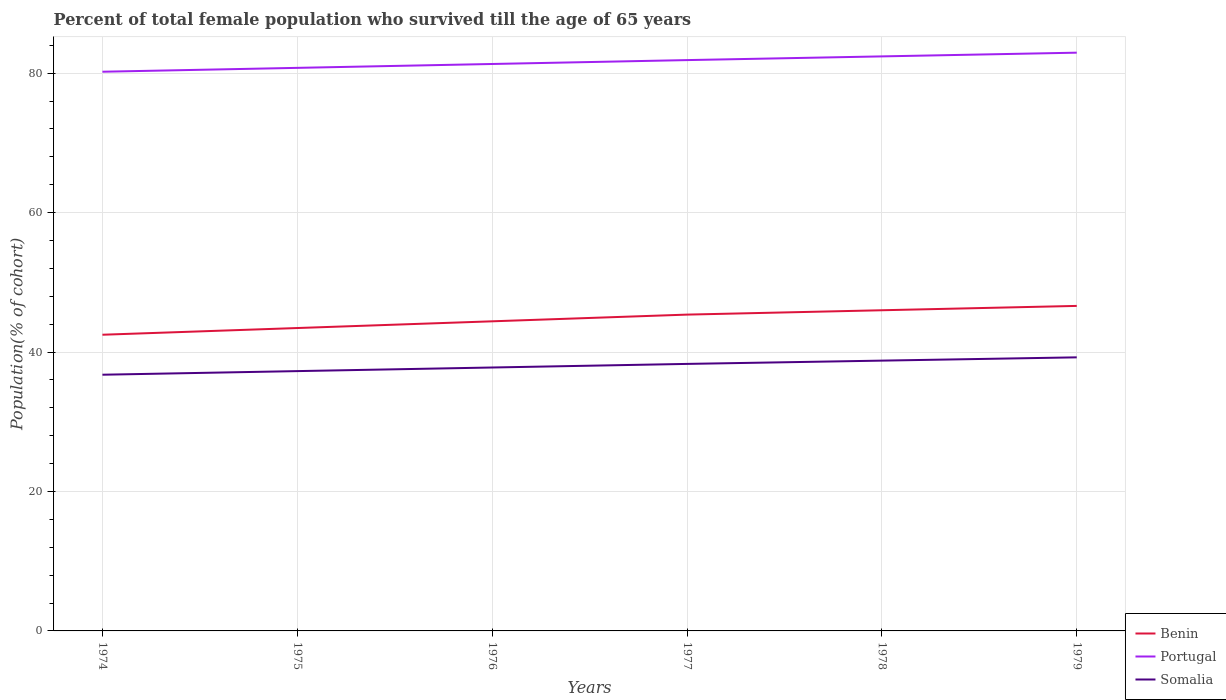Is the number of lines equal to the number of legend labels?
Your answer should be very brief. Yes. Across all years, what is the maximum percentage of total female population who survived till the age of 65 years in Benin?
Your answer should be compact. 42.48. In which year was the percentage of total female population who survived till the age of 65 years in Somalia maximum?
Offer a very short reply. 1974. What is the total percentage of total female population who survived till the age of 65 years in Portugal in the graph?
Keep it short and to the point. -0.53. What is the difference between the highest and the second highest percentage of total female population who survived till the age of 65 years in Portugal?
Make the answer very short. 2.73. What is the difference between the highest and the lowest percentage of total female population who survived till the age of 65 years in Portugal?
Offer a terse response. 3. Is the percentage of total female population who survived till the age of 65 years in Benin strictly greater than the percentage of total female population who survived till the age of 65 years in Somalia over the years?
Give a very brief answer. No. How many years are there in the graph?
Ensure brevity in your answer.  6. Are the values on the major ticks of Y-axis written in scientific E-notation?
Provide a short and direct response. No. Does the graph contain any zero values?
Your answer should be compact. No. How many legend labels are there?
Offer a terse response. 3. How are the legend labels stacked?
Offer a very short reply. Vertical. What is the title of the graph?
Your answer should be very brief. Percent of total female population who survived till the age of 65 years. What is the label or title of the X-axis?
Provide a succinct answer. Years. What is the label or title of the Y-axis?
Provide a short and direct response. Population(% of cohort). What is the Population(% of cohort) in Benin in 1974?
Provide a short and direct response. 42.48. What is the Population(% of cohort) in Portugal in 1974?
Your response must be concise. 80.2. What is the Population(% of cohort) of Somalia in 1974?
Your response must be concise. 36.75. What is the Population(% of cohort) in Benin in 1975?
Offer a terse response. 43.44. What is the Population(% of cohort) of Portugal in 1975?
Your response must be concise. 80.76. What is the Population(% of cohort) in Somalia in 1975?
Offer a very short reply. 37.26. What is the Population(% of cohort) in Benin in 1976?
Ensure brevity in your answer.  44.4. What is the Population(% of cohort) in Portugal in 1976?
Provide a succinct answer. 81.31. What is the Population(% of cohort) in Somalia in 1976?
Provide a succinct answer. 37.78. What is the Population(% of cohort) of Benin in 1977?
Make the answer very short. 45.37. What is the Population(% of cohort) in Portugal in 1977?
Make the answer very short. 81.87. What is the Population(% of cohort) in Somalia in 1977?
Your answer should be very brief. 38.3. What is the Population(% of cohort) of Benin in 1978?
Your answer should be very brief. 45.99. What is the Population(% of cohort) in Portugal in 1978?
Your answer should be very brief. 82.4. What is the Population(% of cohort) in Somalia in 1978?
Your response must be concise. 38.77. What is the Population(% of cohort) in Benin in 1979?
Provide a succinct answer. 46.61. What is the Population(% of cohort) in Portugal in 1979?
Ensure brevity in your answer.  82.93. What is the Population(% of cohort) in Somalia in 1979?
Ensure brevity in your answer.  39.24. Across all years, what is the maximum Population(% of cohort) of Benin?
Ensure brevity in your answer.  46.61. Across all years, what is the maximum Population(% of cohort) of Portugal?
Offer a very short reply. 82.93. Across all years, what is the maximum Population(% of cohort) of Somalia?
Offer a very short reply. 39.24. Across all years, what is the minimum Population(% of cohort) of Benin?
Provide a succinct answer. 42.48. Across all years, what is the minimum Population(% of cohort) of Portugal?
Your answer should be very brief. 80.2. Across all years, what is the minimum Population(% of cohort) in Somalia?
Your response must be concise. 36.75. What is the total Population(% of cohort) in Benin in the graph?
Your answer should be very brief. 268.3. What is the total Population(% of cohort) of Portugal in the graph?
Ensure brevity in your answer.  489.47. What is the total Population(% of cohort) of Somalia in the graph?
Provide a succinct answer. 228.09. What is the difference between the Population(% of cohort) in Benin in 1974 and that in 1975?
Your answer should be compact. -0.96. What is the difference between the Population(% of cohort) in Portugal in 1974 and that in 1975?
Offer a very short reply. -0.56. What is the difference between the Population(% of cohort) in Somalia in 1974 and that in 1975?
Your answer should be compact. -0.52. What is the difference between the Population(% of cohort) of Benin in 1974 and that in 1976?
Offer a very short reply. -1.92. What is the difference between the Population(% of cohort) of Portugal in 1974 and that in 1976?
Your response must be concise. -1.11. What is the difference between the Population(% of cohort) in Somalia in 1974 and that in 1976?
Your answer should be compact. -1.03. What is the difference between the Population(% of cohort) of Benin in 1974 and that in 1977?
Make the answer very short. -2.89. What is the difference between the Population(% of cohort) in Portugal in 1974 and that in 1977?
Provide a short and direct response. -1.67. What is the difference between the Population(% of cohort) of Somalia in 1974 and that in 1977?
Your response must be concise. -1.55. What is the difference between the Population(% of cohort) of Benin in 1974 and that in 1978?
Provide a short and direct response. -3.51. What is the difference between the Population(% of cohort) of Portugal in 1974 and that in 1978?
Offer a terse response. -2.2. What is the difference between the Population(% of cohort) in Somalia in 1974 and that in 1978?
Offer a very short reply. -2.02. What is the difference between the Population(% of cohort) of Benin in 1974 and that in 1979?
Provide a succinct answer. -4.13. What is the difference between the Population(% of cohort) of Portugal in 1974 and that in 1979?
Make the answer very short. -2.73. What is the difference between the Population(% of cohort) in Somalia in 1974 and that in 1979?
Make the answer very short. -2.49. What is the difference between the Population(% of cohort) in Benin in 1975 and that in 1976?
Your answer should be compact. -0.96. What is the difference between the Population(% of cohort) of Portugal in 1975 and that in 1976?
Provide a short and direct response. -0.56. What is the difference between the Population(% of cohort) of Somalia in 1975 and that in 1976?
Provide a succinct answer. -0.52. What is the difference between the Population(% of cohort) of Benin in 1975 and that in 1977?
Ensure brevity in your answer.  -1.92. What is the difference between the Population(% of cohort) of Portugal in 1975 and that in 1977?
Provide a short and direct response. -1.11. What is the difference between the Population(% of cohort) of Somalia in 1975 and that in 1977?
Give a very brief answer. -1.03. What is the difference between the Population(% of cohort) of Benin in 1975 and that in 1978?
Provide a short and direct response. -2.55. What is the difference between the Population(% of cohort) in Portugal in 1975 and that in 1978?
Your answer should be very brief. -1.65. What is the difference between the Population(% of cohort) in Somalia in 1975 and that in 1978?
Keep it short and to the point. -1.5. What is the difference between the Population(% of cohort) in Benin in 1975 and that in 1979?
Keep it short and to the point. -3.17. What is the difference between the Population(% of cohort) in Portugal in 1975 and that in 1979?
Provide a short and direct response. -2.18. What is the difference between the Population(% of cohort) in Somalia in 1975 and that in 1979?
Offer a very short reply. -1.98. What is the difference between the Population(% of cohort) in Benin in 1976 and that in 1977?
Provide a succinct answer. -0.96. What is the difference between the Population(% of cohort) in Portugal in 1976 and that in 1977?
Your response must be concise. -0.56. What is the difference between the Population(% of cohort) of Somalia in 1976 and that in 1977?
Your response must be concise. -0.52. What is the difference between the Population(% of cohort) of Benin in 1976 and that in 1978?
Your answer should be compact. -1.59. What is the difference between the Population(% of cohort) of Portugal in 1976 and that in 1978?
Give a very brief answer. -1.09. What is the difference between the Population(% of cohort) of Somalia in 1976 and that in 1978?
Your answer should be very brief. -0.99. What is the difference between the Population(% of cohort) of Benin in 1976 and that in 1979?
Offer a very short reply. -2.21. What is the difference between the Population(% of cohort) in Portugal in 1976 and that in 1979?
Your answer should be very brief. -1.62. What is the difference between the Population(% of cohort) in Somalia in 1976 and that in 1979?
Your response must be concise. -1.46. What is the difference between the Population(% of cohort) of Benin in 1977 and that in 1978?
Provide a succinct answer. -0.62. What is the difference between the Population(% of cohort) in Portugal in 1977 and that in 1978?
Keep it short and to the point. -0.53. What is the difference between the Population(% of cohort) in Somalia in 1977 and that in 1978?
Offer a terse response. -0.47. What is the difference between the Population(% of cohort) in Benin in 1977 and that in 1979?
Make the answer very short. -1.25. What is the difference between the Population(% of cohort) in Portugal in 1977 and that in 1979?
Your answer should be compact. -1.06. What is the difference between the Population(% of cohort) in Somalia in 1977 and that in 1979?
Offer a very short reply. -0.94. What is the difference between the Population(% of cohort) in Benin in 1978 and that in 1979?
Your answer should be very brief. -0.62. What is the difference between the Population(% of cohort) of Portugal in 1978 and that in 1979?
Your answer should be very brief. -0.53. What is the difference between the Population(% of cohort) in Somalia in 1978 and that in 1979?
Your response must be concise. -0.47. What is the difference between the Population(% of cohort) of Benin in 1974 and the Population(% of cohort) of Portugal in 1975?
Ensure brevity in your answer.  -38.28. What is the difference between the Population(% of cohort) in Benin in 1974 and the Population(% of cohort) in Somalia in 1975?
Provide a succinct answer. 5.22. What is the difference between the Population(% of cohort) of Portugal in 1974 and the Population(% of cohort) of Somalia in 1975?
Keep it short and to the point. 42.94. What is the difference between the Population(% of cohort) in Benin in 1974 and the Population(% of cohort) in Portugal in 1976?
Offer a very short reply. -38.83. What is the difference between the Population(% of cohort) in Benin in 1974 and the Population(% of cohort) in Somalia in 1976?
Your answer should be compact. 4.7. What is the difference between the Population(% of cohort) in Portugal in 1974 and the Population(% of cohort) in Somalia in 1976?
Offer a terse response. 42.42. What is the difference between the Population(% of cohort) of Benin in 1974 and the Population(% of cohort) of Portugal in 1977?
Offer a very short reply. -39.39. What is the difference between the Population(% of cohort) of Benin in 1974 and the Population(% of cohort) of Somalia in 1977?
Offer a terse response. 4.18. What is the difference between the Population(% of cohort) in Portugal in 1974 and the Population(% of cohort) in Somalia in 1977?
Keep it short and to the point. 41.9. What is the difference between the Population(% of cohort) in Benin in 1974 and the Population(% of cohort) in Portugal in 1978?
Provide a short and direct response. -39.92. What is the difference between the Population(% of cohort) in Benin in 1974 and the Population(% of cohort) in Somalia in 1978?
Make the answer very short. 3.71. What is the difference between the Population(% of cohort) of Portugal in 1974 and the Population(% of cohort) of Somalia in 1978?
Make the answer very short. 41.43. What is the difference between the Population(% of cohort) in Benin in 1974 and the Population(% of cohort) in Portugal in 1979?
Provide a short and direct response. -40.45. What is the difference between the Population(% of cohort) of Benin in 1974 and the Population(% of cohort) of Somalia in 1979?
Make the answer very short. 3.24. What is the difference between the Population(% of cohort) of Portugal in 1974 and the Population(% of cohort) of Somalia in 1979?
Your response must be concise. 40.96. What is the difference between the Population(% of cohort) of Benin in 1975 and the Population(% of cohort) of Portugal in 1976?
Your answer should be very brief. -37.87. What is the difference between the Population(% of cohort) in Benin in 1975 and the Population(% of cohort) in Somalia in 1976?
Your answer should be very brief. 5.66. What is the difference between the Population(% of cohort) of Portugal in 1975 and the Population(% of cohort) of Somalia in 1976?
Keep it short and to the point. 42.98. What is the difference between the Population(% of cohort) in Benin in 1975 and the Population(% of cohort) in Portugal in 1977?
Offer a terse response. -38.43. What is the difference between the Population(% of cohort) in Benin in 1975 and the Population(% of cohort) in Somalia in 1977?
Provide a succinct answer. 5.15. What is the difference between the Population(% of cohort) of Portugal in 1975 and the Population(% of cohort) of Somalia in 1977?
Offer a very short reply. 42.46. What is the difference between the Population(% of cohort) of Benin in 1975 and the Population(% of cohort) of Portugal in 1978?
Keep it short and to the point. -38.96. What is the difference between the Population(% of cohort) in Benin in 1975 and the Population(% of cohort) in Somalia in 1978?
Make the answer very short. 4.67. What is the difference between the Population(% of cohort) in Portugal in 1975 and the Population(% of cohort) in Somalia in 1978?
Your answer should be compact. 41.99. What is the difference between the Population(% of cohort) in Benin in 1975 and the Population(% of cohort) in Portugal in 1979?
Offer a very short reply. -39.49. What is the difference between the Population(% of cohort) of Benin in 1975 and the Population(% of cohort) of Somalia in 1979?
Your answer should be very brief. 4.2. What is the difference between the Population(% of cohort) in Portugal in 1975 and the Population(% of cohort) in Somalia in 1979?
Make the answer very short. 41.52. What is the difference between the Population(% of cohort) of Benin in 1976 and the Population(% of cohort) of Portugal in 1977?
Your answer should be very brief. -37.46. What is the difference between the Population(% of cohort) of Benin in 1976 and the Population(% of cohort) of Somalia in 1977?
Provide a succinct answer. 6.11. What is the difference between the Population(% of cohort) in Portugal in 1976 and the Population(% of cohort) in Somalia in 1977?
Offer a terse response. 43.02. What is the difference between the Population(% of cohort) of Benin in 1976 and the Population(% of cohort) of Portugal in 1978?
Offer a terse response. -38. What is the difference between the Population(% of cohort) in Benin in 1976 and the Population(% of cohort) in Somalia in 1978?
Keep it short and to the point. 5.64. What is the difference between the Population(% of cohort) in Portugal in 1976 and the Population(% of cohort) in Somalia in 1978?
Ensure brevity in your answer.  42.54. What is the difference between the Population(% of cohort) of Benin in 1976 and the Population(% of cohort) of Portugal in 1979?
Keep it short and to the point. -38.53. What is the difference between the Population(% of cohort) of Benin in 1976 and the Population(% of cohort) of Somalia in 1979?
Make the answer very short. 5.17. What is the difference between the Population(% of cohort) of Portugal in 1976 and the Population(% of cohort) of Somalia in 1979?
Make the answer very short. 42.07. What is the difference between the Population(% of cohort) of Benin in 1977 and the Population(% of cohort) of Portugal in 1978?
Ensure brevity in your answer.  -37.03. What is the difference between the Population(% of cohort) of Benin in 1977 and the Population(% of cohort) of Somalia in 1978?
Your response must be concise. 6.6. What is the difference between the Population(% of cohort) in Portugal in 1977 and the Population(% of cohort) in Somalia in 1978?
Make the answer very short. 43.1. What is the difference between the Population(% of cohort) of Benin in 1977 and the Population(% of cohort) of Portugal in 1979?
Your answer should be compact. -37.57. What is the difference between the Population(% of cohort) in Benin in 1977 and the Population(% of cohort) in Somalia in 1979?
Give a very brief answer. 6.13. What is the difference between the Population(% of cohort) in Portugal in 1977 and the Population(% of cohort) in Somalia in 1979?
Provide a short and direct response. 42.63. What is the difference between the Population(% of cohort) in Benin in 1978 and the Population(% of cohort) in Portugal in 1979?
Offer a terse response. -36.94. What is the difference between the Population(% of cohort) of Benin in 1978 and the Population(% of cohort) of Somalia in 1979?
Keep it short and to the point. 6.75. What is the difference between the Population(% of cohort) of Portugal in 1978 and the Population(% of cohort) of Somalia in 1979?
Your answer should be very brief. 43.16. What is the average Population(% of cohort) in Benin per year?
Your answer should be very brief. 44.72. What is the average Population(% of cohort) in Portugal per year?
Give a very brief answer. 81.58. What is the average Population(% of cohort) of Somalia per year?
Keep it short and to the point. 38.01. In the year 1974, what is the difference between the Population(% of cohort) in Benin and Population(% of cohort) in Portugal?
Provide a short and direct response. -37.72. In the year 1974, what is the difference between the Population(% of cohort) in Benin and Population(% of cohort) in Somalia?
Your answer should be compact. 5.73. In the year 1974, what is the difference between the Population(% of cohort) of Portugal and Population(% of cohort) of Somalia?
Make the answer very short. 43.45. In the year 1975, what is the difference between the Population(% of cohort) of Benin and Population(% of cohort) of Portugal?
Offer a terse response. -37.31. In the year 1975, what is the difference between the Population(% of cohort) of Benin and Population(% of cohort) of Somalia?
Ensure brevity in your answer.  6.18. In the year 1975, what is the difference between the Population(% of cohort) in Portugal and Population(% of cohort) in Somalia?
Make the answer very short. 43.49. In the year 1976, what is the difference between the Population(% of cohort) in Benin and Population(% of cohort) in Portugal?
Give a very brief answer. -36.91. In the year 1976, what is the difference between the Population(% of cohort) of Benin and Population(% of cohort) of Somalia?
Ensure brevity in your answer.  6.62. In the year 1976, what is the difference between the Population(% of cohort) in Portugal and Population(% of cohort) in Somalia?
Make the answer very short. 43.53. In the year 1977, what is the difference between the Population(% of cohort) in Benin and Population(% of cohort) in Portugal?
Keep it short and to the point. -36.5. In the year 1977, what is the difference between the Population(% of cohort) of Benin and Population(% of cohort) of Somalia?
Provide a succinct answer. 7.07. In the year 1977, what is the difference between the Population(% of cohort) in Portugal and Population(% of cohort) in Somalia?
Keep it short and to the point. 43.57. In the year 1978, what is the difference between the Population(% of cohort) of Benin and Population(% of cohort) of Portugal?
Provide a short and direct response. -36.41. In the year 1978, what is the difference between the Population(% of cohort) of Benin and Population(% of cohort) of Somalia?
Make the answer very short. 7.22. In the year 1978, what is the difference between the Population(% of cohort) in Portugal and Population(% of cohort) in Somalia?
Your response must be concise. 43.63. In the year 1979, what is the difference between the Population(% of cohort) of Benin and Population(% of cohort) of Portugal?
Your answer should be very brief. -36.32. In the year 1979, what is the difference between the Population(% of cohort) in Benin and Population(% of cohort) in Somalia?
Ensure brevity in your answer.  7.38. In the year 1979, what is the difference between the Population(% of cohort) of Portugal and Population(% of cohort) of Somalia?
Offer a very short reply. 43.69. What is the ratio of the Population(% of cohort) of Benin in 1974 to that in 1975?
Your response must be concise. 0.98. What is the ratio of the Population(% of cohort) of Somalia in 1974 to that in 1975?
Keep it short and to the point. 0.99. What is the ratio of the Population(% of cohort) of Benin in 1974 to that in 1976?
Ensure brevity in your answer.  0.96. What is the ratio of the Population(% of cohort) in Portugal in 1974 to that in 1976?
Provide a succinct answer. 0.99. What is the ratio of the Population(% of cohort) of Somalia in 1974 to that in 1976?
Provide a succinct answer. 0.97. What is the ratio of the Population(% of cohort) in Benin in 1974 to that in 1977?
Your answer should be very brief. 0.94. What is the ratio of the Population(% of cohort) in Portugal in 1974 to that in 1977?
Offer a terse response. 0.98. What is the ratio of the Population(% of cohort) of Somalia in 1974 to that in 1977?
Provide a short and direct response. 0.96. What is the ratio of the Population(% of cohort) in Benin in 1974 to that in 1978?
Provide a succinct answer. 0.92. What is the ratio of the Population(% of cohort) in Portugal in 1974 to that in 1978?
Provide a short and direct response. 0.97. What is the ratio of the Population(% of cohort) in Somalia in 1974 to that in 1978?
Provide a succinct answer. 0.95. What is the ratio of the Population(% of cohort) in Benin in 1974 to that in 1979?
Offer a terse response. 0.91. What is the ratio of the Population(% of cohort) of Somalia in 1974 to that in 1979?
Give a very brief answer. 0.94. What is the ratio of the Population(% of cohort) of Benin in 1975 to that in 1976?
Your response must be concise. 0.98. What is the ratio of the Population(% of cohort) of Somalia in 1975 to that in 1976?
Give a very brief answer. 0.99. What is the ratio of the Population(% of cohort) in Benin in 1975 to that in 1977?
Provide a succinct answer. 0.96. What is the ratio of the Population(% of cohort) of Portugal in 1975 to that in 1977?
Give a very brief answer. 0.99. What is the ratio of the Population(% of cohort) in Somalia in 1975 to that in 1977?
Your answer should be compact. 0.97. What is the ratio of the Population(% of cohort) in Benin in 1975 to that in 1978?
Your response must be concise. 0.94. What is the ratio of the Population(% of cohort) of Portugal in 1975 to that in 1978?
Offer a very short reply. 0.98. What is the ratio of the Population(% of cohort) of Somalia in 1975 to that in 1978?
Offer a very short reply. 0.96. What is the ratio of the Population(% of cohort) in Benin in 1975 to that in 1979?
Make the answer very short. 0.93. What is the ratio of the Population(% of cohort) in Portugal in 1975 to that in 1979?
Offer a terse response. 0.97. What is the ratio of the Population(% of cohort) in Somalia in 1975 to that in 1979?
Give a very brief answer. 0.95. What is the ratio of the Population(% of cohort) of Benin in 1976 to that in 1977?
Give a very brief answer. 0.98. What is the ratio of the Population(% of cohort) in Somalia in 1976 to that in 1977?
Your response must be concise. 0.99. What is the ratio of the Population(% of cohort) in Benin in 1976 to that in 1978?
Provide a short and direct response. 0.97. What is the ratio of the Population(% of cohort) in Somalia in 1976 to that in 1978?
Provide a succinct answer. 0.97. What is the ratio of the Population(% of cohort) of Benin in 1976 to that in 1979?
Offer a terse response. 0.95. What is the ratio of the Population(% of cohort) of Portugal in 1976 to that in 1979?
Your answer should be very brief. 0.98. What is the ratio of the Population(% of cohort) in Somalia in 1976 to that in 1979?
Ensure brevity in your answer.  0.96. What is the ratio of the Population(% of cohort) of Benin in 1977 to that in 1978?
Ensure brevity in your answer.  0.99. What is the ratio of the Population(% of cohort) of Somalia in 1977 to that in 1978?
Provide a short and direct response. 0.99. What is the ratio of the Population(% of cohort) in Benin in 1977 to that in 1979?
Keep it short and to the point. 0.97. What is the ratio of the Population(% of cohort) of Portugal in 1977 to that in 1979?
Provide a succinct answer. 0.99. What is the ratio of the Population(% of cohort) in Somalia in 1977 to that in 1979?
Your answer should be very brief. 0.98. What is the ratio of the Population(% of cohort) of Benin in 1978 to that in 1979?
Your answer should be very brief. 0.99. What is the ratio of the Population(% of cohort) in Somalia in 1978 to that in 1979?
Make the answer very short. 0.99. What is the difference between the highest and the second highest Population(% of cohort) in Benin?
Give a very brief answer. 0.62. What is the difference between the highest and the second highest Population(% of cohort) in Portugal?
Offer a terse response. 0.53. What is the difference between the highest and the second highest Population(% of cohort) of Somalia?
Offer a terse response. 0.47. What is the difference between the highest and the lowest Population(% of cohort) of Benin?
Your answer should be very brief. 4.13. What is the difference between the highest and the lowest Population(% of cohort) in Portugal?
Provide a short and direct response. 2.73. What is the difference between the highest and the lowest Population(% of cohort) of Somalia?
Your answer should be compact. 2.49. 